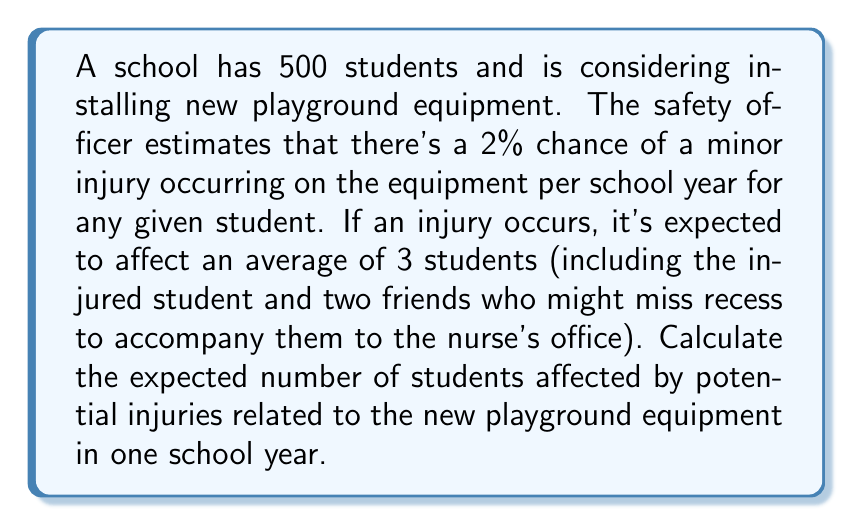Give your solution to this math problem. Let's approach this step-by-step:

1) First, we need to calculate the probability of at least one injury occurring:
   $P(\text{at least one injury}) = 1 - P(\text{no injuries})$
   $P(\text{no injuries}) = (0.98)^{500}$ (because each student has a 98% chance of not being injured)
   $P(\text{at least one injury}) = 1 - (0.98)^{500} \approx 0.9999999999999999$

2) Now, let's define our random variable:
   Let $X$ be the number of students affected by injuries in a school year.

3) We can calculate the expected value of $X$ as follows:
   $E(X) = P(\text{at least one injury}) \times (\text{average number of students affected per injury}) \times (\text{expected number of injuries})$

4) We know:
   - $P(\text{at least one injury}) \approx 0.9999999999999999$
   - Average number of students affected per injury = 3
   - Expected number of injuries = 500 × 0.02 = 10 (because each of the 500 students has a 2% chance of injury)

5) Plugging these values into our equation:
   $E(X) \approx 0.9999999999999999 \times 3 \times 10 = 29.999999999999997$

6) Rounding to a reasonable number of decimal places:
   $E(X) \approx 30$
Answer: 30 students 